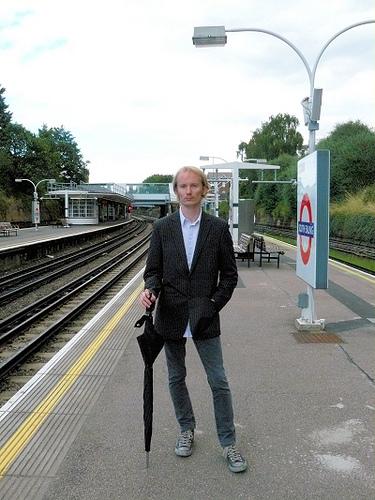Is this man wearing sneakers?
Write a very short answer. Yes. Is the man at a railway station?
Keep it brief. Yes. Does this man need the umbrella?
Keep it brief. No. 